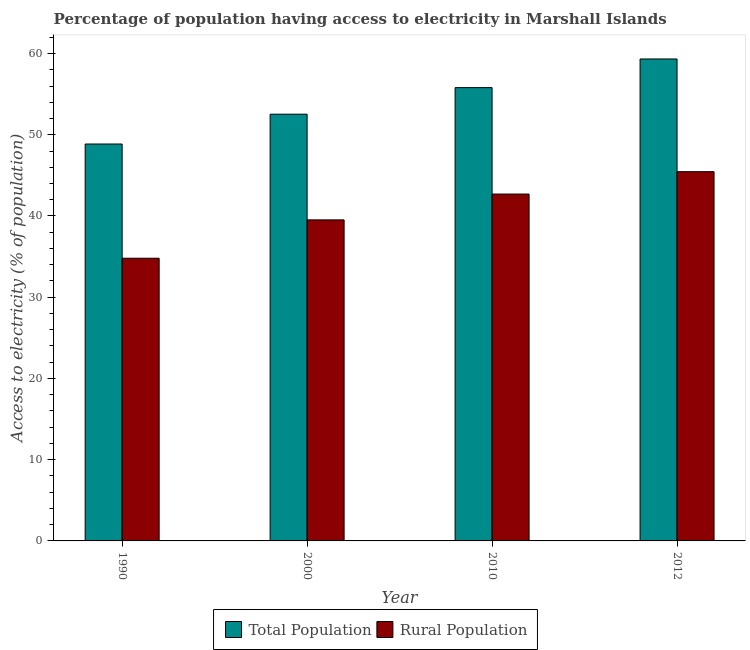How many different coloured bars are there?
Ensure brevity in your answer.  2. How many groups of bars are there?
Your answer should be very brief. 4. Are the number of bars per tick equal to the number of legend labels?
Offer a very short reply. Yes. Are the number of bars on each tick of the X-axis equal?
Offer a very short reply. Yes. How many bars are there on the 4th tick from the left?
Provide a succinct answer. 2. What is the percentage of rural population having access to electricity in 2000?
Your response must be concise. 39.52. Across all years, what is the maximum percentage of rural population having access to electricity?
Give a very brief answer. 45.45. Across all years, what is the minimum percentage of population having access to electricity?
Provide a short and direct response. 48.86. In which year was the percentage of population having access to electricity maximum?
Keep it short and to the point. 2012. What is the total percentage of rural population having access to electricity in the graph?
Offer a very short reply. 162.47. What is the difference between the percentage of rural population having access to electricity in 2000 and that in 2010?
Ensure brevity in your answer.  -3.18. What is the difference between the percentage of rural population having access to electricity in 1990 and the percentage of population having access to electricity in 2010?
Your answer should be compact. -7.9. What is the average percentage of rural population having access to electricity per year?
Keep it short and to the point. 40.62. In the year 1990, what is the difference between the percentage of population having access to electricity and percentage of rural population having access to electricity?
Offer a terse response. 0. What is the ratio of the percentage of population having access to electricity in 2000 to that in 2010?
Provide a short and direct response. 0.94. What is the difference between the highest and the second highest percentage of population having access to electricity?
Make the answer very short. 3.53. What is the difference between the highest and the lowest percentage of rural population having access to electricity?
Provide a short and direct response. 10.66. In how many years, is the percentage of rural population having access to electricity greater than the average percentage of rural population having access to electricity taken over all years?
Provide a short and direct response. 2. What does the 1st bar from the left in 1990 represents?
Keep it short and to the point. Total Population. What does the 2nd bar from the right in 2010 represents?
Your answer should be very brief. Total Population. How many years are there in the graph?
Offer a very short reply. 4. What is the difference between two consecutive major ticks on the Y-axis?
Provide a short and direct response. 10. Are the values on the major ticks of Y-axis written in scientific E-notation?
Your answer should be compact. No. Where does the legend appear in the graph?
Your answer should be very brief. Bottom center. What is the title of the graph?
Your answer should be compact. Percentage of population having access to electricity in Marshall Islands. What is the label or title of the Y-axis?
Make the answer very short. Access to electricity (% of population). What is the Access to electricity (% of population) of Total Population in 1990?
Keep it short and to the point. 48.86. What is the Access to electricity (% of population) in Rural Population in 1990?
Keep it short and to the point. 34.8. What is the Access to electricity (% of population) of Total Population in 2000?
Give a very brief answer. 52.53. What is the Access to electricity (% of population) in Rural Population in 2000?
Keep it short and to the point. 39.52. What is the Access to electricity (% of population) of Total Population in 2010?
Give a very brief answer. 55.8. What is the Access to electricity (% of population) of Rural Population in 2010?
Offer a very short reply. 42.7. What is the Access to electricity (% of population) in Total Population in 2012?
Make the answer very short. 59.33. What is the Access to electricity (% of population) in Rural Population in 2012?
Ensure brevity in your answer.  45.45. Across all years, what is the maximum Access to electricity (% of population) of Total Population?
Offer a very short reply. 59.33. Across all years, what is the maximum Access to electricity (% of population) of Rural Population?
Give a very brief answer. 45.45. Across all years, what is the minimum Access to electricity (% of population) in Total Population?
Provide a succinct answer. 48.86. Across all years, what is the minimum Access to electricity (% of population) of Rural Population?
Provide a succinct answer. 34.8. What is the total Access to electricity (% of population) in Total Population in the graph?
Your answer should be compact. 216.52. What is the total Access to electricity (% of population) of Rural Population in the graph?
Ensure brevity in your answer.  162.47. What is the difference between the Access to electricity (% of population) of Total Population in 1990 and that in 2000?
Your answer should be very brief. -3.67. What is the difference between the Access to electricity (% of population) of Rural Population in 1990 and that in 2000?
Provide a succinct answer. -4.72. What is the difference between the Access to electricity (% of population) in Total Population in 1990 and that in 2010?
Your response must be concise. -6.94. What is the difference between the Access to electricity (% of population) in Rural Population in 1990 and that in 2010?
Offer a very short reply. -7.9. What is the difference between the Access to electricity (% of population) of Total Population in 1990 and that in 2012?
Your answer should be compact. -10.47. What is the difference between the Access to electricity (% of population) in Rural Population in 1990 and that in 2012?
Your answer should be compact. -10.66. What is the difference between the Access to electricity (% of population) of Total Population in 2000 and that in 2010?
Keep it short and to the point. -3.27. What is the difference between the Access to electricity (% of population) of Rural Population in 2000 and that in 2010?
Your answer should be compact. -3.18. What is the difference between the Access to electricity (% of population) of Total Population in 2000 and that in 2012?
Offer a very short reply. -6.8. What is the difference between the Access to electricity (% of population) in Rural Population in 2000 and that in 2012?
Make the answer very short. -5.93. What is the difference between the Access to electricity (% of population) in Total Population in 2010 and that in 2012?
Offer a terse response. -3.53. What is the difference between the Access to electricity (% of population) in Rural Population in 2010 and that in 2012?
Provide a succinct answer. -2.75. What is the difference between the Access to electricity (% of population) of Total Population in 1990 and the Access to electricity (% of population) of Rural Population in 2000?
Offer a very short reply. 9.34. What is the difference between the Access to electricity (% of population) of Total Population in 1990 and the Access to electricity (% of population) of Rural Population in 2010?
Ensure brevity in your answer.  6.16. What is the difference between the Access to electricity (% of population) of Total Population in 1990 and the Access to electricity (% of population) of Rural Population in 2012?
Provide a short and direct response. 3.4. What is the difference between the Access to electricity (% of population) in Total Population in 2000 and the Access to electricity (% of population) in Rural Population in 2010?
Your answer should be compact. 9.83. What is the difference between the Access to electricity (% of population) in Total Population in 2000 and the Access to electricity (% of population) in Rural Population in 2012?
Give a very brief answer. 7.08. What is the difference between the Access to electricity (% of population) in Total Population in 2010 and the Access to electricity (% of population) in Rural Population in 2012?
Keep it short and to the point. 10.35. What is the average Access to electricity (% of population) in Total Population per year?
Give a very brief answer. 54.13. What is the average Access to electricity (% of population) of Rural Population per year?
Keep it short and to the point. 40.62. In the year 1990, what is the difference between the Access to electricity (% of population) in Total Population and Access to electricity (% of population) in Rural Population?
Give a very brief answer. 14.06. In the year 2000, what is the difference between the Access to electricity (% of population) in Total Population and Access to electricity (% of population) in Rural Population?
Your response must be concise. 13.01. In the year 2012, what is the difference between the Access to electricity (% of population) in Total Population and Access to electricity (% of population) in Rural Population?
Provide a short and direct response. 13.87. What is the ratio of the Access to electricity (% of population) in Total Population in 1990 to that in 2000?
Offer a very short reply. 0.93. What is the ratio of the Access to electricity (% of population) of Rural Population in 1990 to that in 2000?
Keep it short and to the point. 0.88. What is the ratio of the Access to electricity (% of population) of Total Population in 1990 to that in 2010?
Provide a succinct answer. 0.88. What is the ratio of the Access to electricity (% of population) in Rural Population in 1990 to that in 2010?
Keep it short and to the point. 0.81. What is the ratio of the Access to electricity (% of population) of Total Population in 1990 to that in 2012?
Your answer should be compact. 0.82. What is the ratio of the Access to electricity (% of population) in Rural Population in 1990 to that in 2012?
Provide a succinct answer. 0.77. What is the ratio of the Access to electricity (% of population) of Total Population in 2000 to that in 2010?
Ensure brevity in your answer.  0.94. What is the ratio of the Access to electricity (% of population) of Rural Population in 2000 to that in 2010?
Your response must be concise. 0.93. What is the ratio of the Access to electricity (% of population) of Total Population in 2000 to that in 2012?
Give a very brief answer. 0.89. What is the ratio of the Access to electricity (% of population) of Rural Population in 2000 to that in 2012?
Offer a very short reply. 0.87. What is the ratio of the Access to electricity (% of population) in Total Population in 2010 to that in 2012?
Your answer should be compact. 0.94. What is the ratio of the Access to electricity (% of population) of Rural Population in 2010 to that in 2012?
Your response must be concise. 0.94. What is the difference between the highest and the second highest Access to electricity (% of population) in Total Population?
Offer a very short reply. 3.53. What is the difference between the highest and the second highest Access to electricity (% of population) of Rural Population?
Keep it short and to the point. 2.75. What is the difference between the highest and the lowest Access to electricity (% of population) of Total Population?
Offer a very short reply. 10.47. What is the difference between the highest and the lowest Access to electricity (% of population) in Rural Population?
Ensure brevity in your answer.  10.66. 